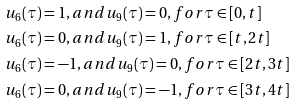<formula> <loc_0><loc_0><loc_500><loc_500>& u _ { 6 } ( \tau ) = 1 , a n d u _ { 9 } ( \tau ) = 0 , f o r \tau \in [ 0 , t ] \\ & u _ { 6 } ( \tau ) = 0 , a n d u _ { 9 } ( \tau ) = 1 , f o r \tau \in [ t , 2 t ] \\ & u _ { 6 } ( \tau ) = - 1 , a n d u _ { 9 } ( \tau ) = 0 , f o r \tau \in [ 2 t , 3 t ] \\ & u _ { 6 } ( \tau ) = 0 , a n d u _ { 9 } ( \tau ) = - 1 , f o r \tau \in [ 3 t , 4 t ]</formula> 